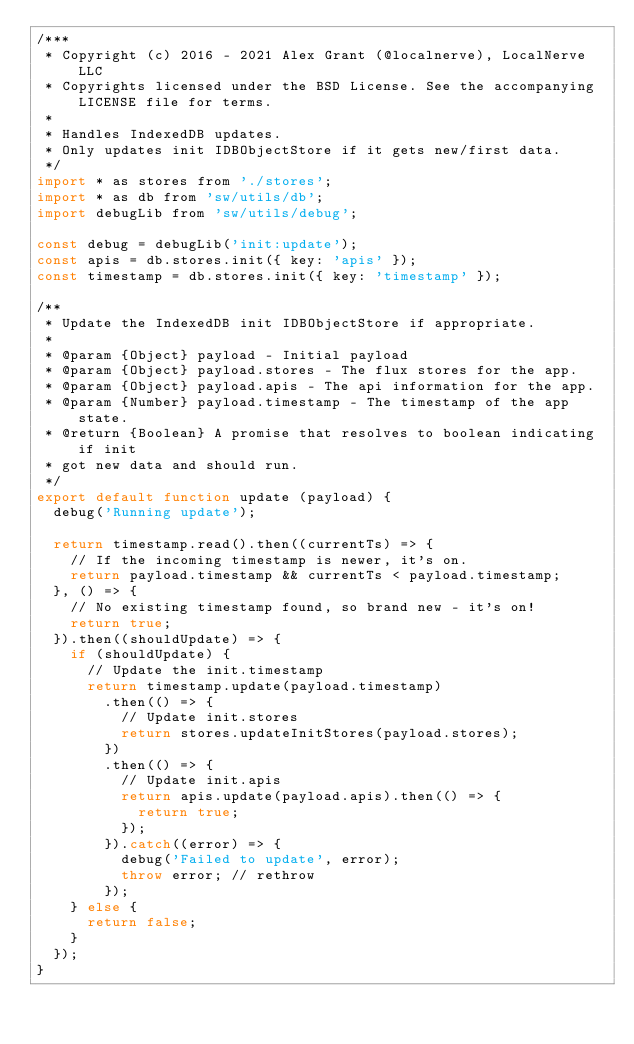<code> <loc_0><loc_0><loc_500><loc_500><_JavaScript_>/***
 * Copyright (c) 2016 - 2021 Alex Grant (@localnerve), LocalNerve LLC
 * Copyrights licensed under the BSD License. See the accompanying LICENSE file for terms.
 *
 * Handles IndexedDB updates.
 * Only updates init IDBObjectStore if it gets new/first data.
 */
import * as stores from './stores';
import * as db from 'sw/utils/db';
import debugLib from 'sw/utils/debug';

const debug = debugLib('init:update');
const apis = db.stores.init({ key: 'apis' });
const timestamp = db.stores.init({ key: 'timestamp' });

/**
 * Update the IndexedDB init IDBObjectStore if appropriate.
 *
 * @param {Object} payload - Initial payload
 * @param {Object} payload.stores - The flux stores for the app.
 * @param {Object} payload.apis - The api information for the app.
 * @param {Number} payload.timestamp - The timestamp of the app state.
 * @return {Boolean} A promise that resolves to boolean indicating if init
 * got new data and should run.
 */
export default function update (payload) {
  debug('Running update');

  return timestamp.read().then((currentTs) => {
    // If the incoming timestamp is newer, it's on.
    return payload.timestamp && currentTs < payload.timestamp;
  }, () => {
    // No existing timestamp found, so brand new - it's on!
    return true;
  }).then((shouldUpdate) => {
    if (shouldUpdate) {
      // Update the init.timestamp
      return timestamp.update(payload.timestamp)
        .then(() => {
          // Update init.stores
          return stores.updateInitStores(payload.stores);
        })
        .then(() => {
          // Update init.apis
          return apis.update(payload.apis).then(() => {
            return true;
          });
        }).catch((error) => {
          debug('Failed to update', error);
          throw error; // rethrow
        });
    } else {
      return false;
    }
  });
}
</code> 